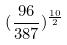<formula> <loc_0><loc_0><loc_500><loc_500>( \frac { 9 6 } { 3 8 7 } ) ^ { \frac { 1 0 } { 2 } }</formula> 